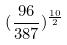<formula> <loc_0><loc_0><loc_500><loc_500>( \frac { 9 6 } { 3 8 7 } ) ^ { \frac { 1 0 } { 2 } }</formula> 